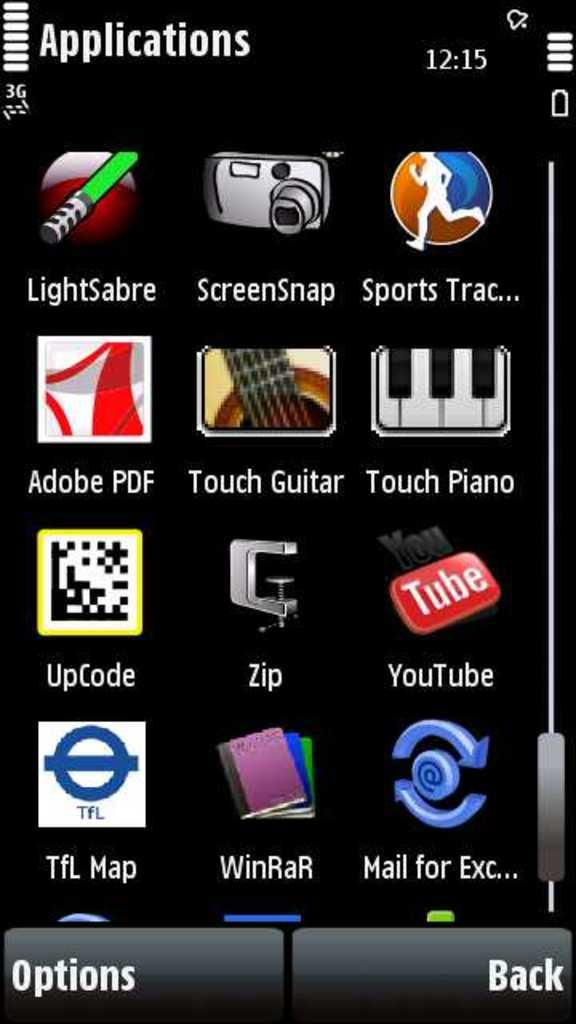<image>
Describe the image concisely. A cell phone screen is open to the Applications tab and YouTube is installed. 